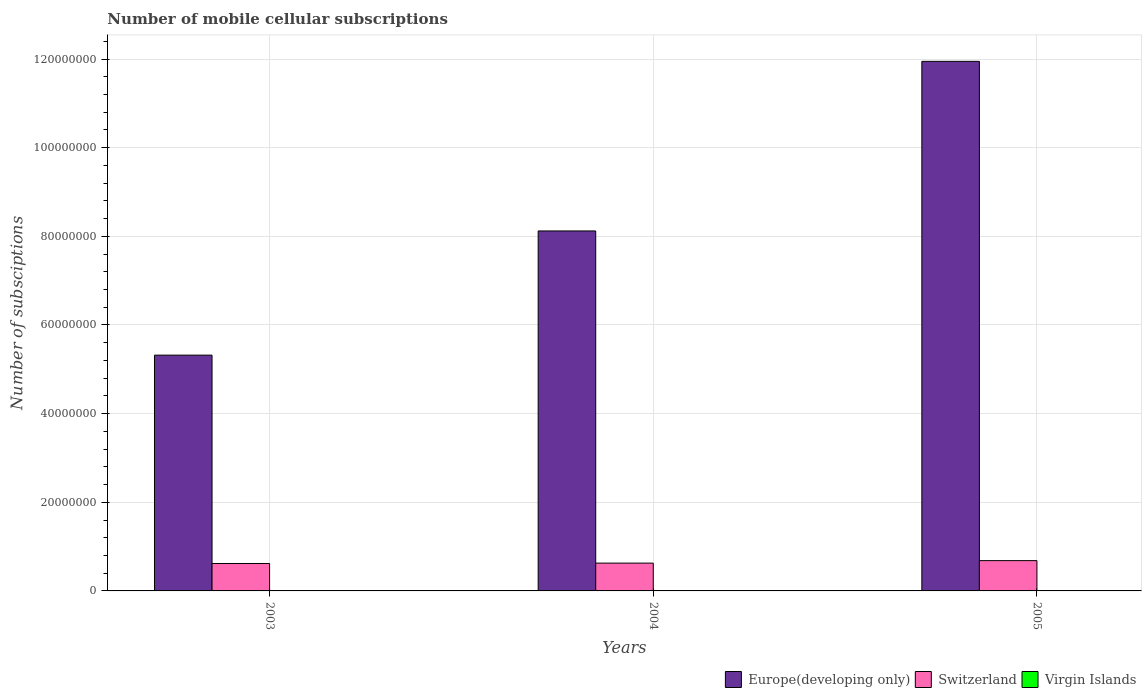How many different coloured bars are there?
Offer a very short reply. 3. How many groups of bars are there?
Your response must be concise. 3. Are the number of bars on each tick of the X-axis equal?
Offer a terse response. Yes. What is the label of the 3rd group of bars from the left?
Your response must be concise. 2005. What is the number of mobile cellular subscriptions in Europe(developing only) in 2005?
Provide a short and direct response. 1.19e+08. Across all years, what is the maximum number of mobile cellular subscriptions in Switzerland?
Keep it short and to the point. 6.83e+06. Across all years, what is the minimum number of mobile cellular subscriptions in Switzerland?
Provide a short and direct response. 6.19e+06. In which year was the number of mobile cellular subscriptions in Europe(developing only) minimum?
Offer a very short reply. 2003. What is the total number of mobile cellular subscriptions in Virgin Islands in the graph?
Your answer should be very brief. 1.94e+05. What is the difference between the number of mobile cellular subscriptions in Europe(developing only) in 2004 and that in 2005?
Provide a short and direct response. -3.83e+07. What is the difference between the number of mobile cellular subscriptions in Switzerland in 2003 and the number of mobile cellular subscriptions in Virgin Islands in 2004?
Make the answer very short. 6.12e+06. What is the average number of mobile cellular subscriptions in Europe(developing only) per year?
Ensure brevity in your answer.  8.46e+07. In the year 2004, what is the difference between the number of mobile cellular subscriptions in Virgin Islands and number of mobile cellular subscriptions in Europe(developing only)?
Offer a very short reply. -8.12e+07. In how many years, is the number of mobile cellular subscriptions in Europe(developing only) greater than 32000000?
Ensure brevity in your answer.  3. What is the ratio of the number of mobile cellular subscriptions in Virgin Islands in 2004 to that in 2005?
Keep it short and to the point. 0.8. Is the number of mobile cellular subscriptions in Virgin Islands in 2003 less than that in 2005?
Make the answer very short. Yes. What is the difference between the highest and the second highest number of mobile cellular subscriptions in Europe(developing only)?
Offer a very short reply. 3.83e+07. What is the difference between the highest and the lowest number of mobile cellular subscriptions in Switzerland?
Offer a very short reply. 6.45e+05. Is the sum of the number of mobile cellular subscriptions in Virgin Islands in 2003 and 2005 greater than the maximum number of mobile cellular subscriptions in Europe(developing only) across all years?
Offer a very short reply. No. What does the 1st bar from the left in 2005 represents?
Offer a terse response. Europe(developing only). What does the 3rd bar from the right in 2004 represents?
Keep it short and to the point. Europe(developing only). Are all the bars in the graph horizontal?
Offer a terse response. No. How many years are there in the graph?
Offer a very short reply. 3. What is the difference between two consecutive major ticks on the Y-axis?
Provide a short and direct response. 2.00e+07. Does the graph contain any zero values?
Keep it short and to the point. No. Does the graph contain grids?
Provide a succinct answer. Yes. How many legend labels are there?
Give a very brief answer. 3. What is the title of the graph?
Your answer should be very brief. Number of mobile cellular subscriptions. Does "Middle East & North Africa (all income levels)" appear as one of the legend labels in the graph?
Offer a very short reply. No. What is the label or title of the Y-axis?
Your response must be concise. Number of subsciptions. What is the Number of subsciptions of Europe(developing only) in 2003?
Ensure brevity in your answer.  5.32e+07. What is the Number of subsciptions of Switzerland in 2003?
Provide a succinct answer. 6.19e+06. What is the Number of subsciptions of Virgin Islands in 2003?
Your response must be concise. 4.93e+04. What is the Number of subsciptions in Europe(developing only) in 2004?
Make the answer very short. 8.12e+07. What is the Number of subsciptions of Switzerland in 2004?
Offer a very short reply. 6.27e+06. What is the Number of subsciptions in Virgin Islands in 2004?
Offer a very short reply. 6.42e+04. What is the Number of subsciptions in Europe(developing only) in 2005?
Give a very brief answer. 1.19e+08. What is the Number of subsciptions in Switzerland in 2005?
Keep it short and to the point. 6.83e+06. What is the Number of subsciptions of Virgin Islands in 2005?
Make the answer very short. 8.03e+04. Across all years, what is the maximum Number of subsciptions of Europe(developing only)?
Your answer should be very brief. 1.19e+08. Across all years, what is the maximum Number of subsciptions in Switzerland?
Your answer should be compact. 6.83e+06. Across all years, what is the maximum Number of subsciptions of Virgin Islands?
Give a very brief answer. 8.03e+04. Across all years, what is the minimum Number of subsciptions of Europe(developing only)?
Provide a short and direct response. 5.32e+07. Across all years, what is the minimum Number of subsciptions of Switzerland?
Give a very brief answer. 6.19e+06. Across all years, what is the minimum Number of subsciptions of Virgin Islands?
Your response must be concise. 4.93e+04. What is the total Number of subsciptions in Europe(developing only) in the graph?
Your response must be concise. 2.54e+08. What is the total Number of subsciptions in Switzerland in the graph?
Provide a succinct answer. 1.93e+07. What is the total Number of subsciptions in Virgin Islands in the graph?
Offer a very short reply. 1.94e+05. What is the difference between the Number of subsciptions of Europe(developing only) in 2003 and that in 2004?
Offer a terse response. -2.80e+07. What is the difference between the Number of subsciptions in Switzerland in 2003 and that in 2004?
Keep it short and to the point. -8.58e+04. What is the difference between the Number of subsciptions of Virgin Islands in 2003 and that in 2004?
Provide a succinct answer. -1.49e+04. What is the difference between the Number of subsciptions of Europe(developing only) in 2003 and that in 2005?
Make the answer very short. -6.63e+07. What is the difference between the Number of subsciptions in Switzerland in 2003 and that in 2005?
Your answer should be compact. -6.45e+05. What is the difference between the Number of subsciptions of Virgin Islands in 2003 and that in 2005?
Your answer should be compact. -3.10e+04. What is the difference between the Number of subsciptions of Europe(developing only) in 2004 and that in 2005?
Offer a terse response. -3.83e+07. What is the difference between the Number of subsciptions in Switzerland in 2004 and that in 2005?
Your response must be concise. -5.59e+05. What is the difference between the Number of subsciptions of Virgin Islands in 2004 and that in 2005?
Your answer should be compact. -1.61e+04. What is the difference between the Number of subsciptions of Europe(developing only) in 2003 and the Number of subsciptions of Switzerland in 2004?
Ensure brevity in your answer.  4.69e+07. What is the difference between the Number of subsciptions in Europe(developing only) in 2003 and the Number of subsciptions in Virgin Islands in 2004?
Offer a very short reply. 5.31e+07. What is the difference between the Number of subsciptions of Switzerland in 2003 and the Number of subsciptions of Virgin Islands in 2004?
Your answer should be very brief. 6.12e+06. What is the difference between the Number of subsciptions in Europe(developing only) in 2003 and the Number of subsciptions in Switzerland in 2005?
Make the answer very short. 4.64e+07. What is the difference between the Number of subsciptions in Europe(developing only) in 2003 and the Number of subsciptions in Virgin Islands in 2005?
Provide a short and direct response. 5.31e+07. What is the difference between the Number of subsciptions of Switzerland in 2003 and the Number of subsciptions of Virgin Islands in 2005?
Keep it short and to the point. 6.11e+06. What is the difference between the Number of subsciptions of Europe(developing only) in 2004 and the Number of subsciptions of Switzerland in 2005?
Give a very brief answer. 7.44e+07. What is the difference between the Number of subsciptions in Europe(developing only) in 2004 and the Number of subsciptions in Virgin Islands in 2005?
Offer a very short reply. 8.11e+07. What is the difference between the Number of subsciptions of Switzerland in 2004 and the Number of subsciptions of Virgin Islands in 2005?
Provide a short and direct response. 6.19e+06. What is the average Number of subsciptions in Europe(developing only) per year?
Provide a succinct answer. 8.46e+07. What is the average Number of subsciptions in Switzerland per year?
Keep it short and to the point. 6.43e+06. What is the average Number of subsciptions of Virgin Islands per year?
Your response must be concise. 6.46e+04. In the year 2003, what is the difference between the Number of subsciptions in Europe(developing only) and Number of subsciptions in Switzerland?
Offer a very short reply. 4.70e+07. In the year 2003, what is the difference between the Number of subsciptions in Europe(developing only) and Number of subsciptions in Virgin Islands?
Ensure brevity in your answer.  5.32e+07. In the year 2003, what is the difference between the Number of subsciptions of Switzerland and Number of subsciptions of Virgin Islands?
Give a very brief answer. 6.14e+06. In the year 2004, what is the difference between the Number of subsciptions of Europe(developing only) and Number of subsciptions of Switzerland?
Offer a very short reply. 7.49e+07. In the year 2004, what is the difference between the Number of subsciptions of Europe(developing only) and Number of subsciptions of Virgin Islands?
Ensure brevity in your answer.  8.12e+07. In the year 2004, what is the difference between the Number of subsciptions of Switzerland and Number of subsciptions of Virgin Islands?
Your response must be concise. 6.21e+06. In the year 2005, what is the difference between the Number of subsciptions in Europe(developing only) and Number of subsciptions in Switzerland?
Your answer should be compact. 1.13e+08. In the year 2005, what is the difference between the Number of subsciptions in Europe(developing only) and Number of subsciptions in Virgin Islands?
Your response must be concise. 1.19e+08. In the year 2005, what is the difference between the Number of subsciptions in Switzerland and Number of subsciptions in Virgin Islands?
Give a very brief answer. 6.75e+06. What is the ratio of the Number of subsciptions in Europe(developing only) in 2003 to that in 2004?
Your response must be concise. 0.66. What is the ratio of the Number of subsciptions of Switzerland in 2003 to that in 2004?
Your answer should be very brief. 0.99. What is the ratio of the Number of subsciptions of Virgin Islands in 2003 to that in 2004?
Give a very brief answer. 0.77. What is the ratio of the Number of subsciptions in Europe(developing only) in 2003 to that in 2005?
Provide a short and direct response. 0.45. What is the ratio of the Number of subsciptions in Switzerland in 2003 to that in 2005?
Give a very brief answer. 0.91. What is the ratio of the Number of subsciptions in Virgin Islands in 2003 to that in 2005?
Give a very brief answer. 0.61. What is the ratio of the Number of subsciptions in Europe(developing only) in 2004 to that in 2005?
Give a very brief answer. 0.68. What is the ratio of the Number of subsciptions in Switzerland in 2004 to that in 2005?
Your response must be concise. 0.92. What is the ratio of the Number of subsciptions of Virgin Islands in 2004 to that in 2005?
Ensure brevity in your answer.  0.8. What is the difference between the highest and the second highest Number of subsciptions in Europe(developing only)?
Offer a very short reply. 3.83e+07. What is the difference between the highest and the second highest Number of subsciptions of Switzerland?
Provide a succinct answer. 5.59e+05. What is the difference between the highest and the second highest Number of subsciptions in Virgin Islands?
Your answer should be compact. 1.61e+04. What is the difference between the highest and the lowest Number of subsciptions in Europe(developing only)?
Your answer should be very brief. 6.63e+07. What is the difference between the highest and the lowest Number of subsciptions in Switzerland?
Your response must be concise. 6.45e+05. What is the difference between the highest and the lowest Number of subsciptions in Virgin Islands?
Your response must be concise. 3.10e+04. 